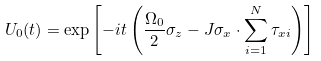<formula> <loc_0><loc_0><loc_500><loc_500>U _ { 0 } ( t ) = \exp \left [ - i t \left ( \frac { \Omega _ { 0 } } { 2 } \sigma _ { z } - J \sigma _ { x } \cdot \sum _ { i = 1 } ^ { N } \tau _ { x i } \right ) \right ]</formula> 